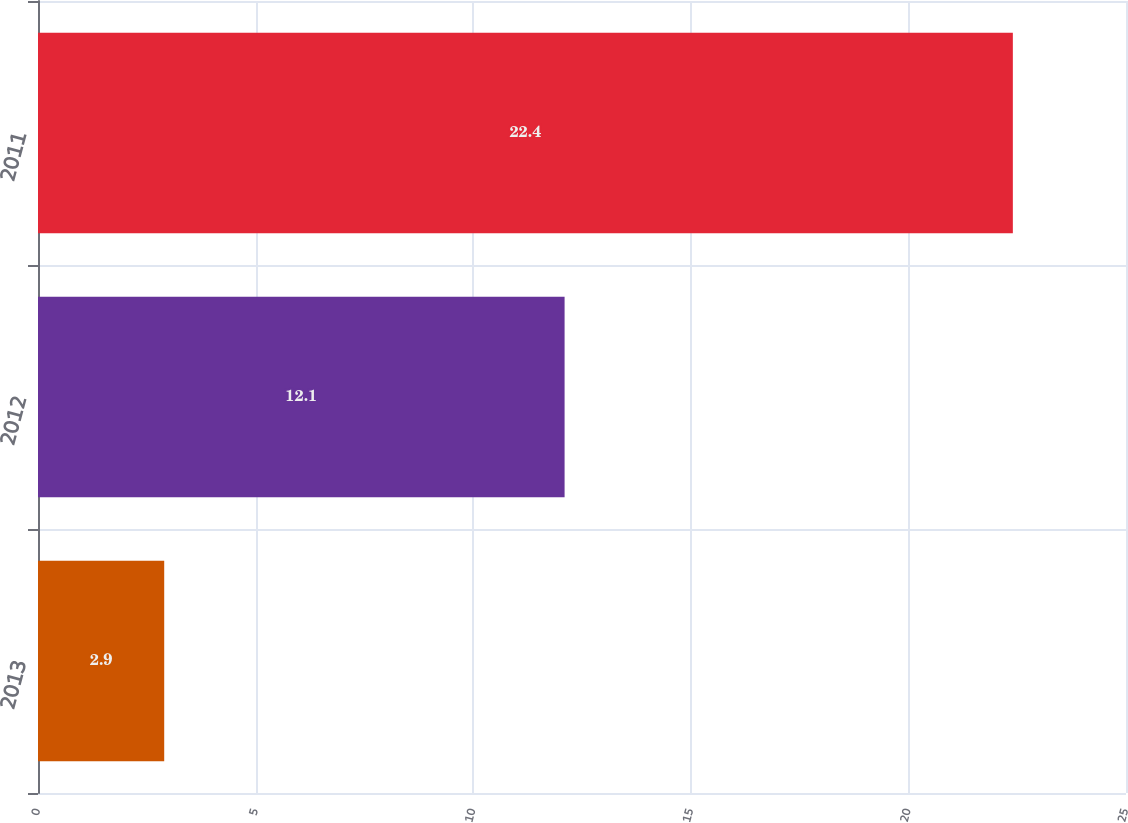<chart> <loc_0><loc_0><loc_500><loc_500><bar_chart><fcel>2013<fcel>2012<fcel>2011<nl><fcel>2.9<fcel>12.1<fcel>22.4<nl></chart> 